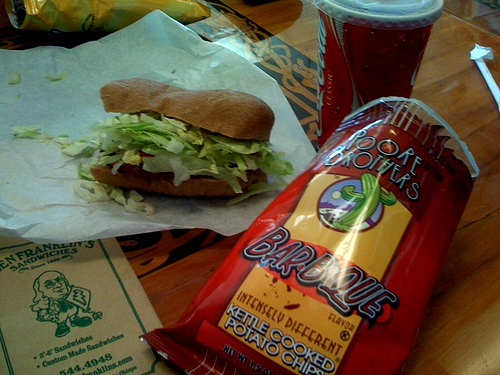Tell me about the restaurant or the setting in the image. The image seems to be taken at a casual dining spot, possibly a sandwich shop, as indicated by the simple wooden table and the paper placemat with branding on it. 